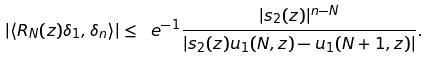<formula> <loc_0><loc_0><loc_500><loc_500>| \langle R _ { N } ( z ) \delta _ { 1 } , \delta _ { n } \rangle | \leq \ e ^ { - 1 } \frac { | s _ { 2 } ( z ) | ^ { n - N } } { | s _ { 2 } ( z ) u _ { 1 } ( N , z ) - u _ { 1 } ( N + 1 , z ) | } .</formula> 